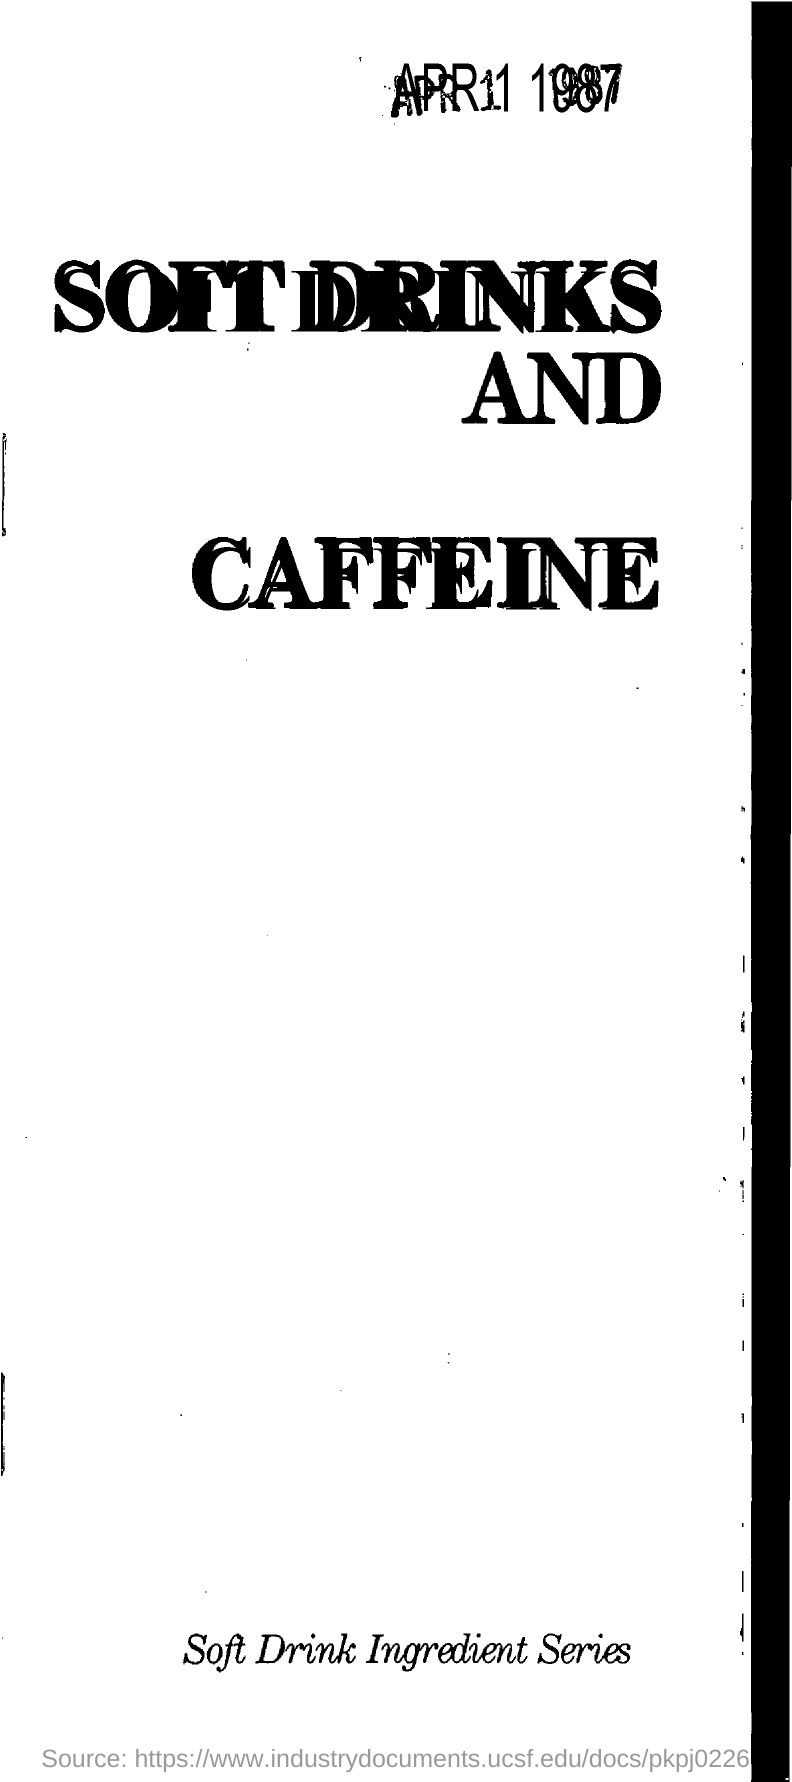Specify some key components in this picture. This document series covers information about the various ingredients used in the production of soft drinks. The title of the document is 'SOFT DRINKS AND CAFFEINE.' The title of the series is "SOFT DRINKS AND CAFFEINE. 